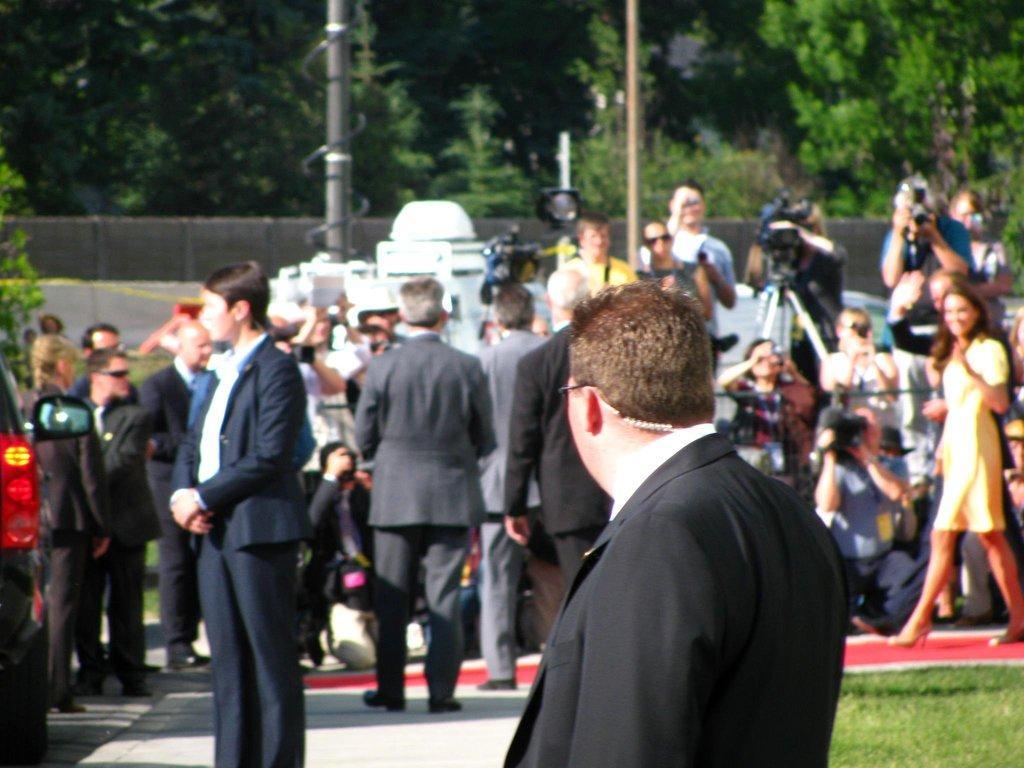How would you summarize this image in a sentence or two? In this image there are some persons standing in the bottom of this image and there is a wall in the middle of this image,and there are some trees on the top of this image. There is a pole on the left side of this image. There is a car in the bottom left corner of this image. 